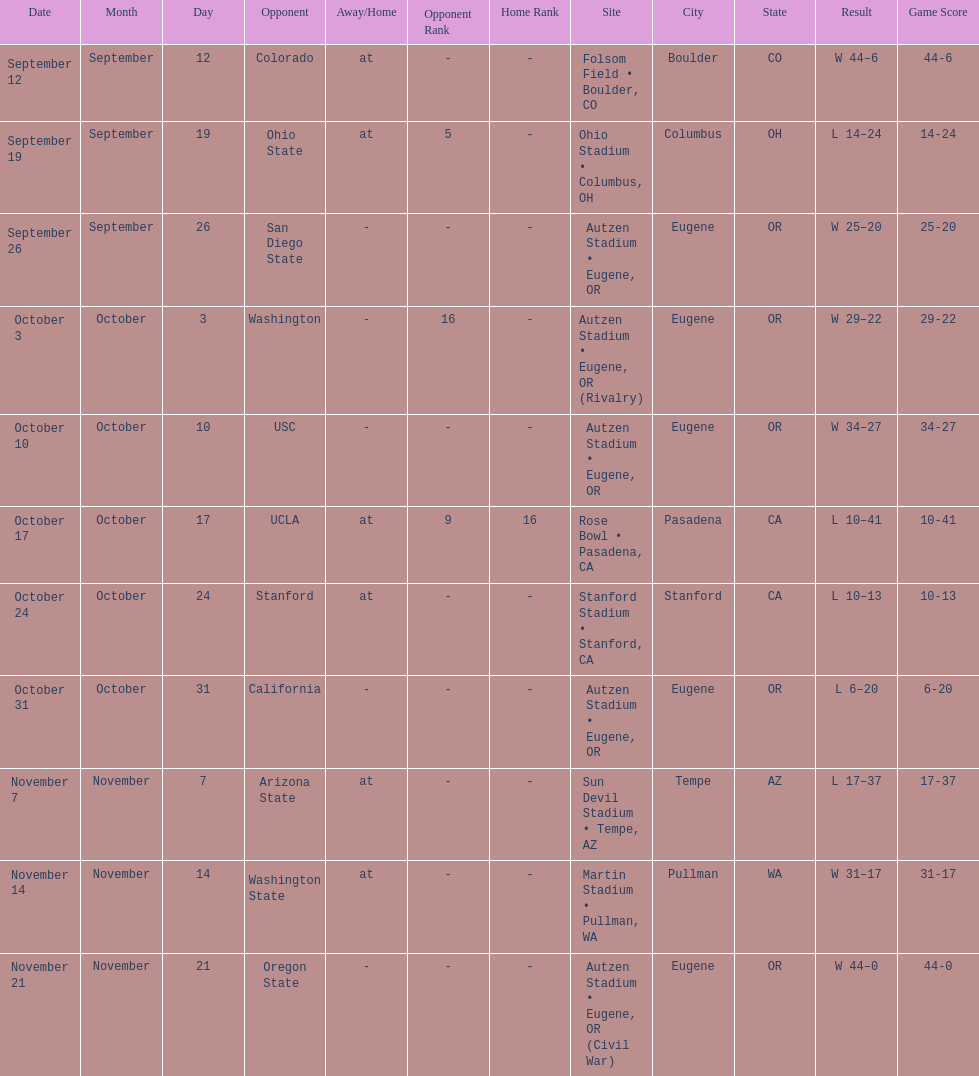Who was their last opponent of the season? Oregon State. 